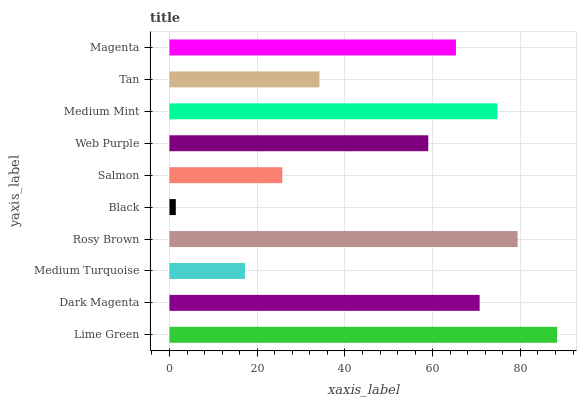Is Black the minimum?
Answer yes or no. Yes. Is Lime Green the maximum?
Answer yes or no. Yes. Is Dark Magenta the minimum?
Answer yes or no. No. Is Dark Magenta the maximum?
Answer yes or no. No. Is Lime Green greater than Dark Magenta?
Answer yes or no. Yes. Is Dark Magenta less than Lime Green?
Answer yes or no. Yes. Is Dark Magenta greater than Lime Green?
Answer yes or no. No. Is Lime Green less than Dark Magenta?
Answer yes or no. No. Is Magenta the high median?
Answer yes or no. Yes. Is Web Purple the low median?
Answer yes or no. Yes. Is Web Purple the high median?
Answer yes or no. No. Is Medium Turquoise the low median?
Answer yes or no. No. 